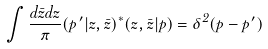<formula> <loc_0><loc_0><loc_500><loc_500>\int { \frac { d \bar { z } d z } { \pi } ( \vec { p } ^ { \, \prime } | z , \bar { z } ) ^ { * } ( z , \bar { z } | \vec { p } ) } = \delta ^ { 2 } ( \vec { p } - \vec { p } ^ { \, \prime } )</formula> 